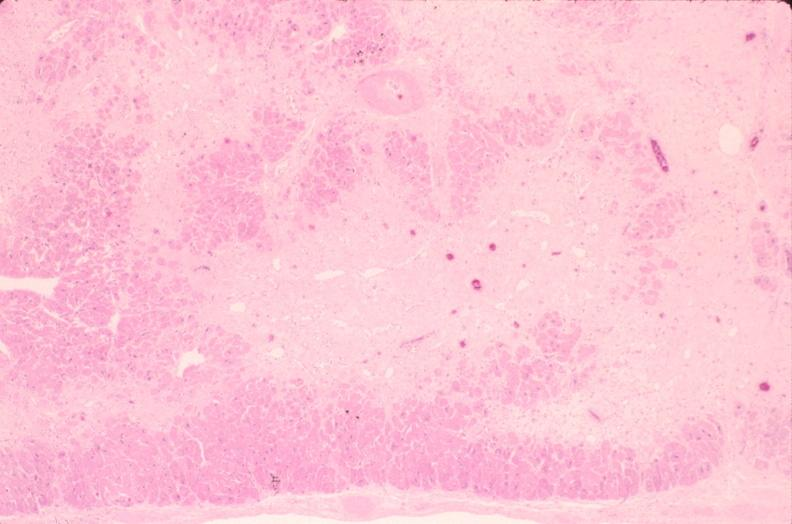where is this in?
Answer the question using a single word or phrase. In heart 